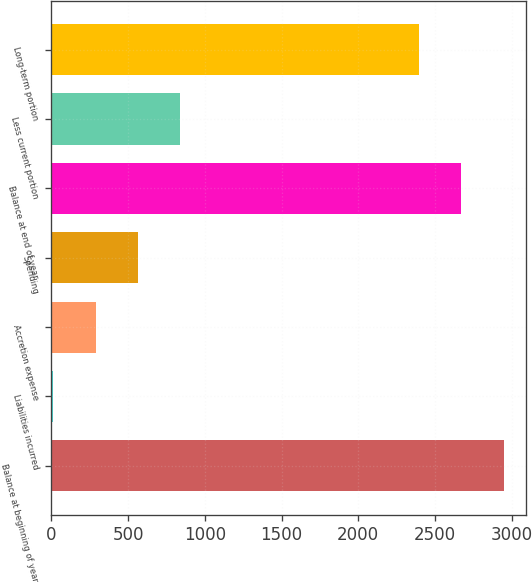Convert chart to OTSL. <chart><loc_0><loc_0><loc_500><loc_500><bar_chart><fcel>Balance at beginning of year<fcel>Liabilities incurred<fcel>Accretion expense<fcel>Spending<fcel>Balance at end of year<fcel>Less current portion<fcel>Long-term portion<nl><fcel>2946.8<fcel>12<fcel>287.9<fcel>563.8<fcel>2670.9<fcel>839.7<fcel>2395<nl></chart> 